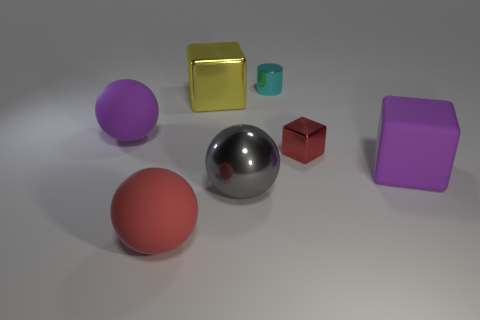Subtract 1 cubes. How many cubes are left? 2 Subtract all shiny cubes. How many cubes are left? 1 Add 1 large gray objects. How many objects exist? 8 Subtract all balls. How many objects are left? 4 Subtract all red metallic objects. Subtract all tiny cubes. How many objects are left? 5 Add 1 purple cubes. How many purple cubes are left? 2 Add 1 big red spheres. How many big red spheres exist? 2 Subtract 0 gray cylinders. How many objects are left? 7 